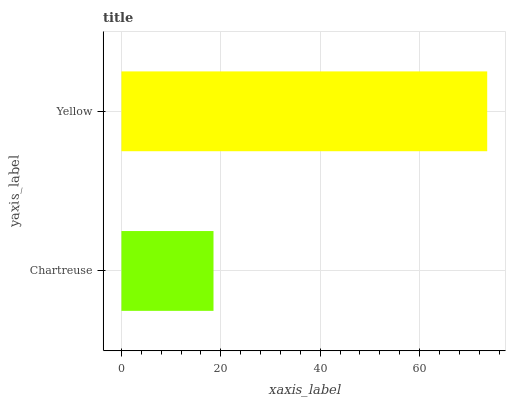Is Chartreuse the minimum?
Answer yes or no. Yes. Is Yellow the maximum?
Answer yes or no. Yes. Is Yellow the minimum?
Answer yes or no. No. Is Yellow greater than Chartreuse?
Answer yes or no. Yes. Is Chartreuse less than Yellow?
Answer yes or no. Yes. Is Chartreuse greater than Yellow?
Answer yes or no. No. Is Yellow less than Chartreuse?
Answer yes or no. No. Is Yellow the high median?
Answer yes or no. Yes. Is Chartreuse the low median?
Answer yes or no. Yes. Is Chartreuse the high median?
Answer yes or no. No. Is Yellow the low median?
Answer yes or no. No. 